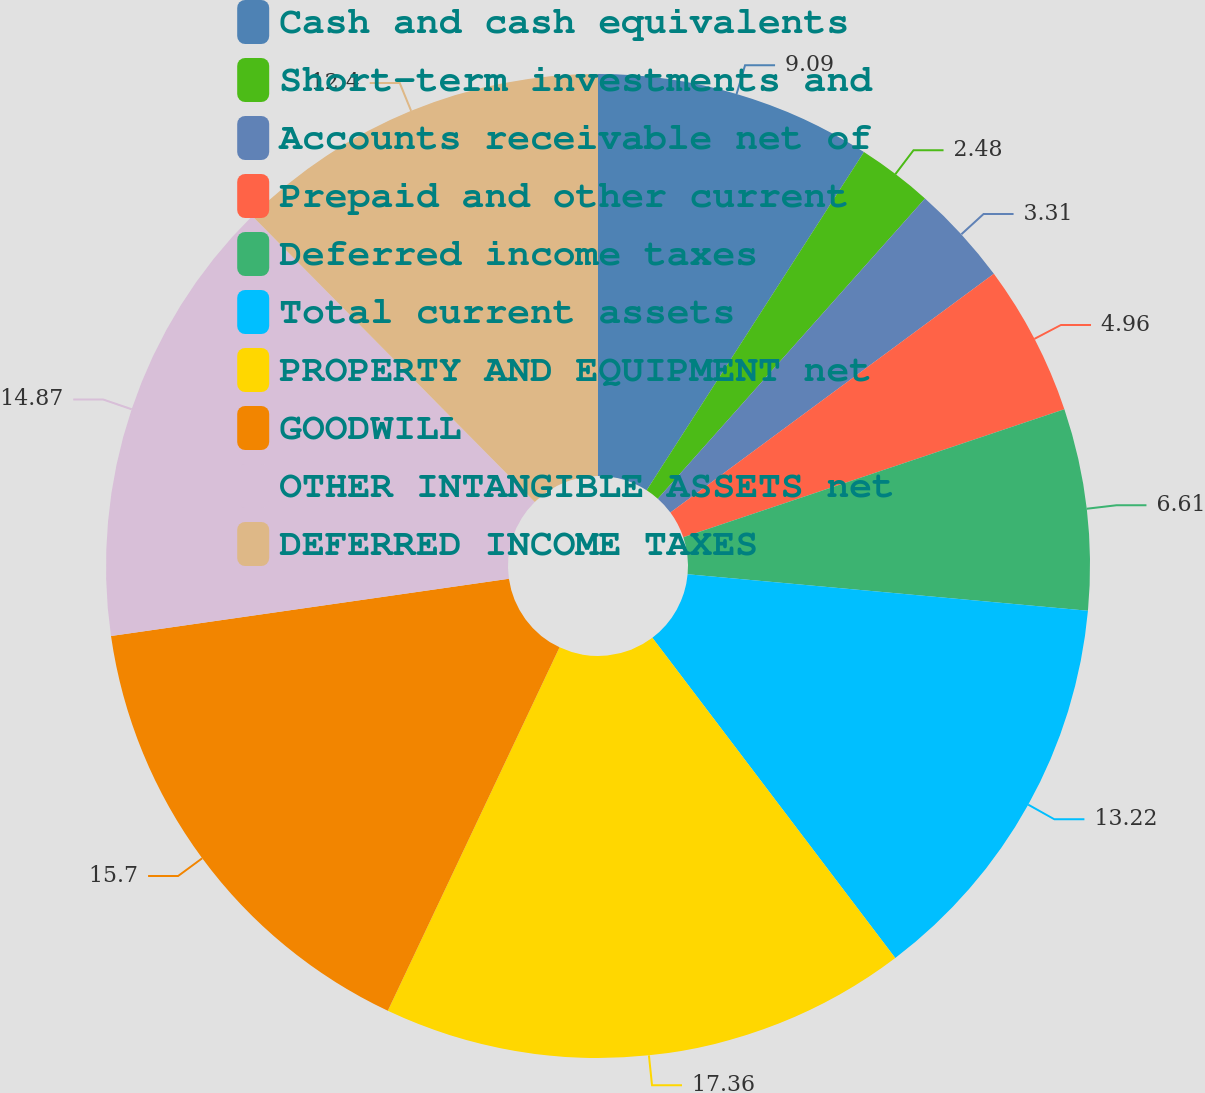<chart> <loc_0><loc_0><loc_500><loc_500><pie_chart><fcel>Cash and cash equivalents<fcel>Short-term investments and<fcel>Accounts receivable net of<fcel>Prepaid and other current<fcel>Deferred income taxes<fcel>Total current assets<fcel>PROPERTY AND EQUIPMENT net<fcel>GOODWILL<fcel>OTHER INTANGIBLE ASSETS net<fcel>DEFERRED INCOME TAXES<nl><fcel>9.09%<fcel>2.48%<fcel>3.31%<fcel>4.96%<fcel>6.61%<fcel>13.22%<fcel>17.35%<fcel>15.7%<fcel>14.87%<fcel>12.4%<nl></chart> 